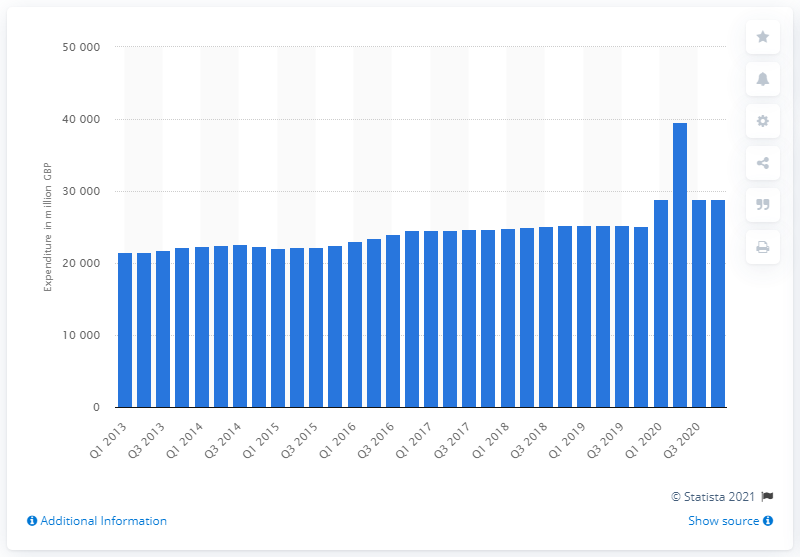Give some essential details in this illustration. The value of food and non-alcoholic drinks purchased by households in the UK during the first quarter of 2020 was approximately 28,955 million pounds. By the fourth quarter of 2020, households in the UK had purchased a total value of 28,955 million pounds worth of food and non-alcoholic drinks. 